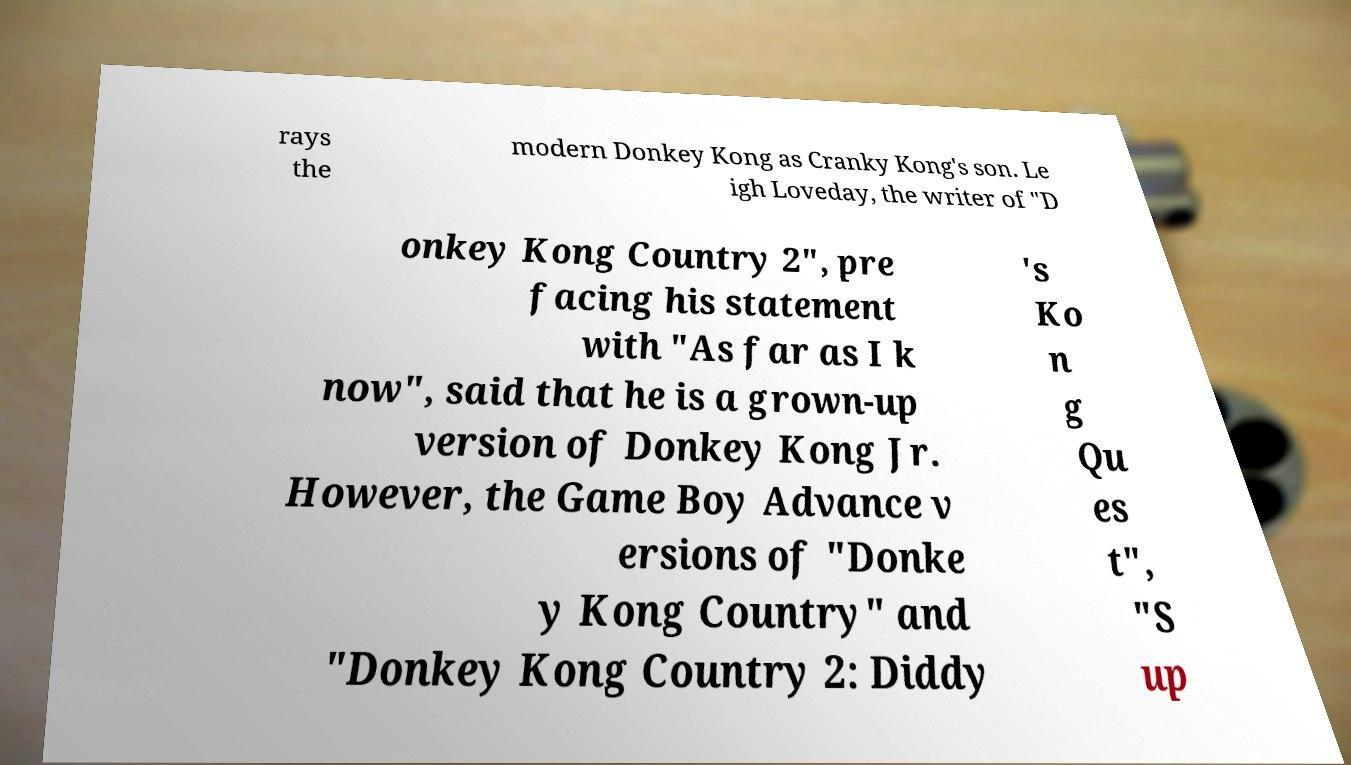Please read and relay the text visible in this image. What does it say? rays the modern Donkey Kong as Cranky Kong's son. Le igh Loveday, the writer of "D onkey Kong Country 2", pre facing his statement with "As far as I k now", said that he is a grown-up version of Donkey Kong Jr. However, the Game Boy Advance v ersions of "Donke y Kong Country" and "Donkey Kong Country 2: Diddy 's Ko n g Qu es t", "S up 